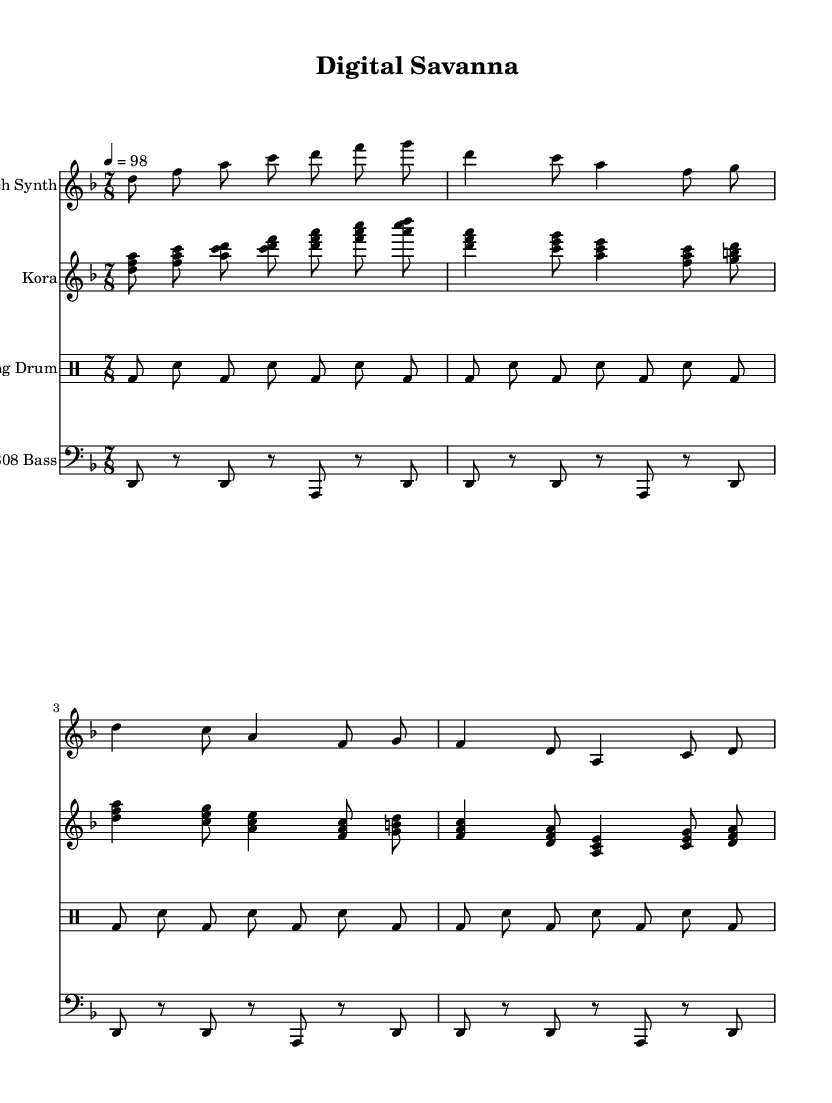What is the key signature of this music? The key signature is identified by the key signature symbol at the beginning of the staff. In this piece, it is set to D minor, which contains one flat (B flat).
Answer: D minor What is the time signature of this piece? The time signature is indicated near the beginning of the staff, following the key signature. Here, it is set to 7/8, which means there are seven eighth notes in a measure.
Answer: 7/8 What is the tempo of the piece? The tempo marking is found at the beginning of the score, which indicates the speed of the music. The marking "4 = 98" means there are 98 beats per minute with the quarter note representing one beat.
Answer: 98 How many measures are in the glitch synth part? To determine the number of measures, count each group of notes separated by bar lines in the glitch synth part. There are a total of four measures in this section of the score.
Answer: 4 What instruments are used in this piece? The instruments can be identified by their respective staff titles at the beginning of each staff. The piece features a Glitch Synth, Kora, Talking Drum, and 808 Bass.
Answer: Glitch Synth, Kora, Talking Drum, 808 Bass How many times does the talking drum pattern repeat? The talking drum part has repeated sections, and by examining the measures, you can see the pattern is repeated four times in total throughout the score.
Answer: 4 Which traditional instrument is featured in this score? The instrument specified in the score that is traditional is the Kora, which is a stringed instrument from West Africa, as indicated in its respective staff.
Answer: Kora 